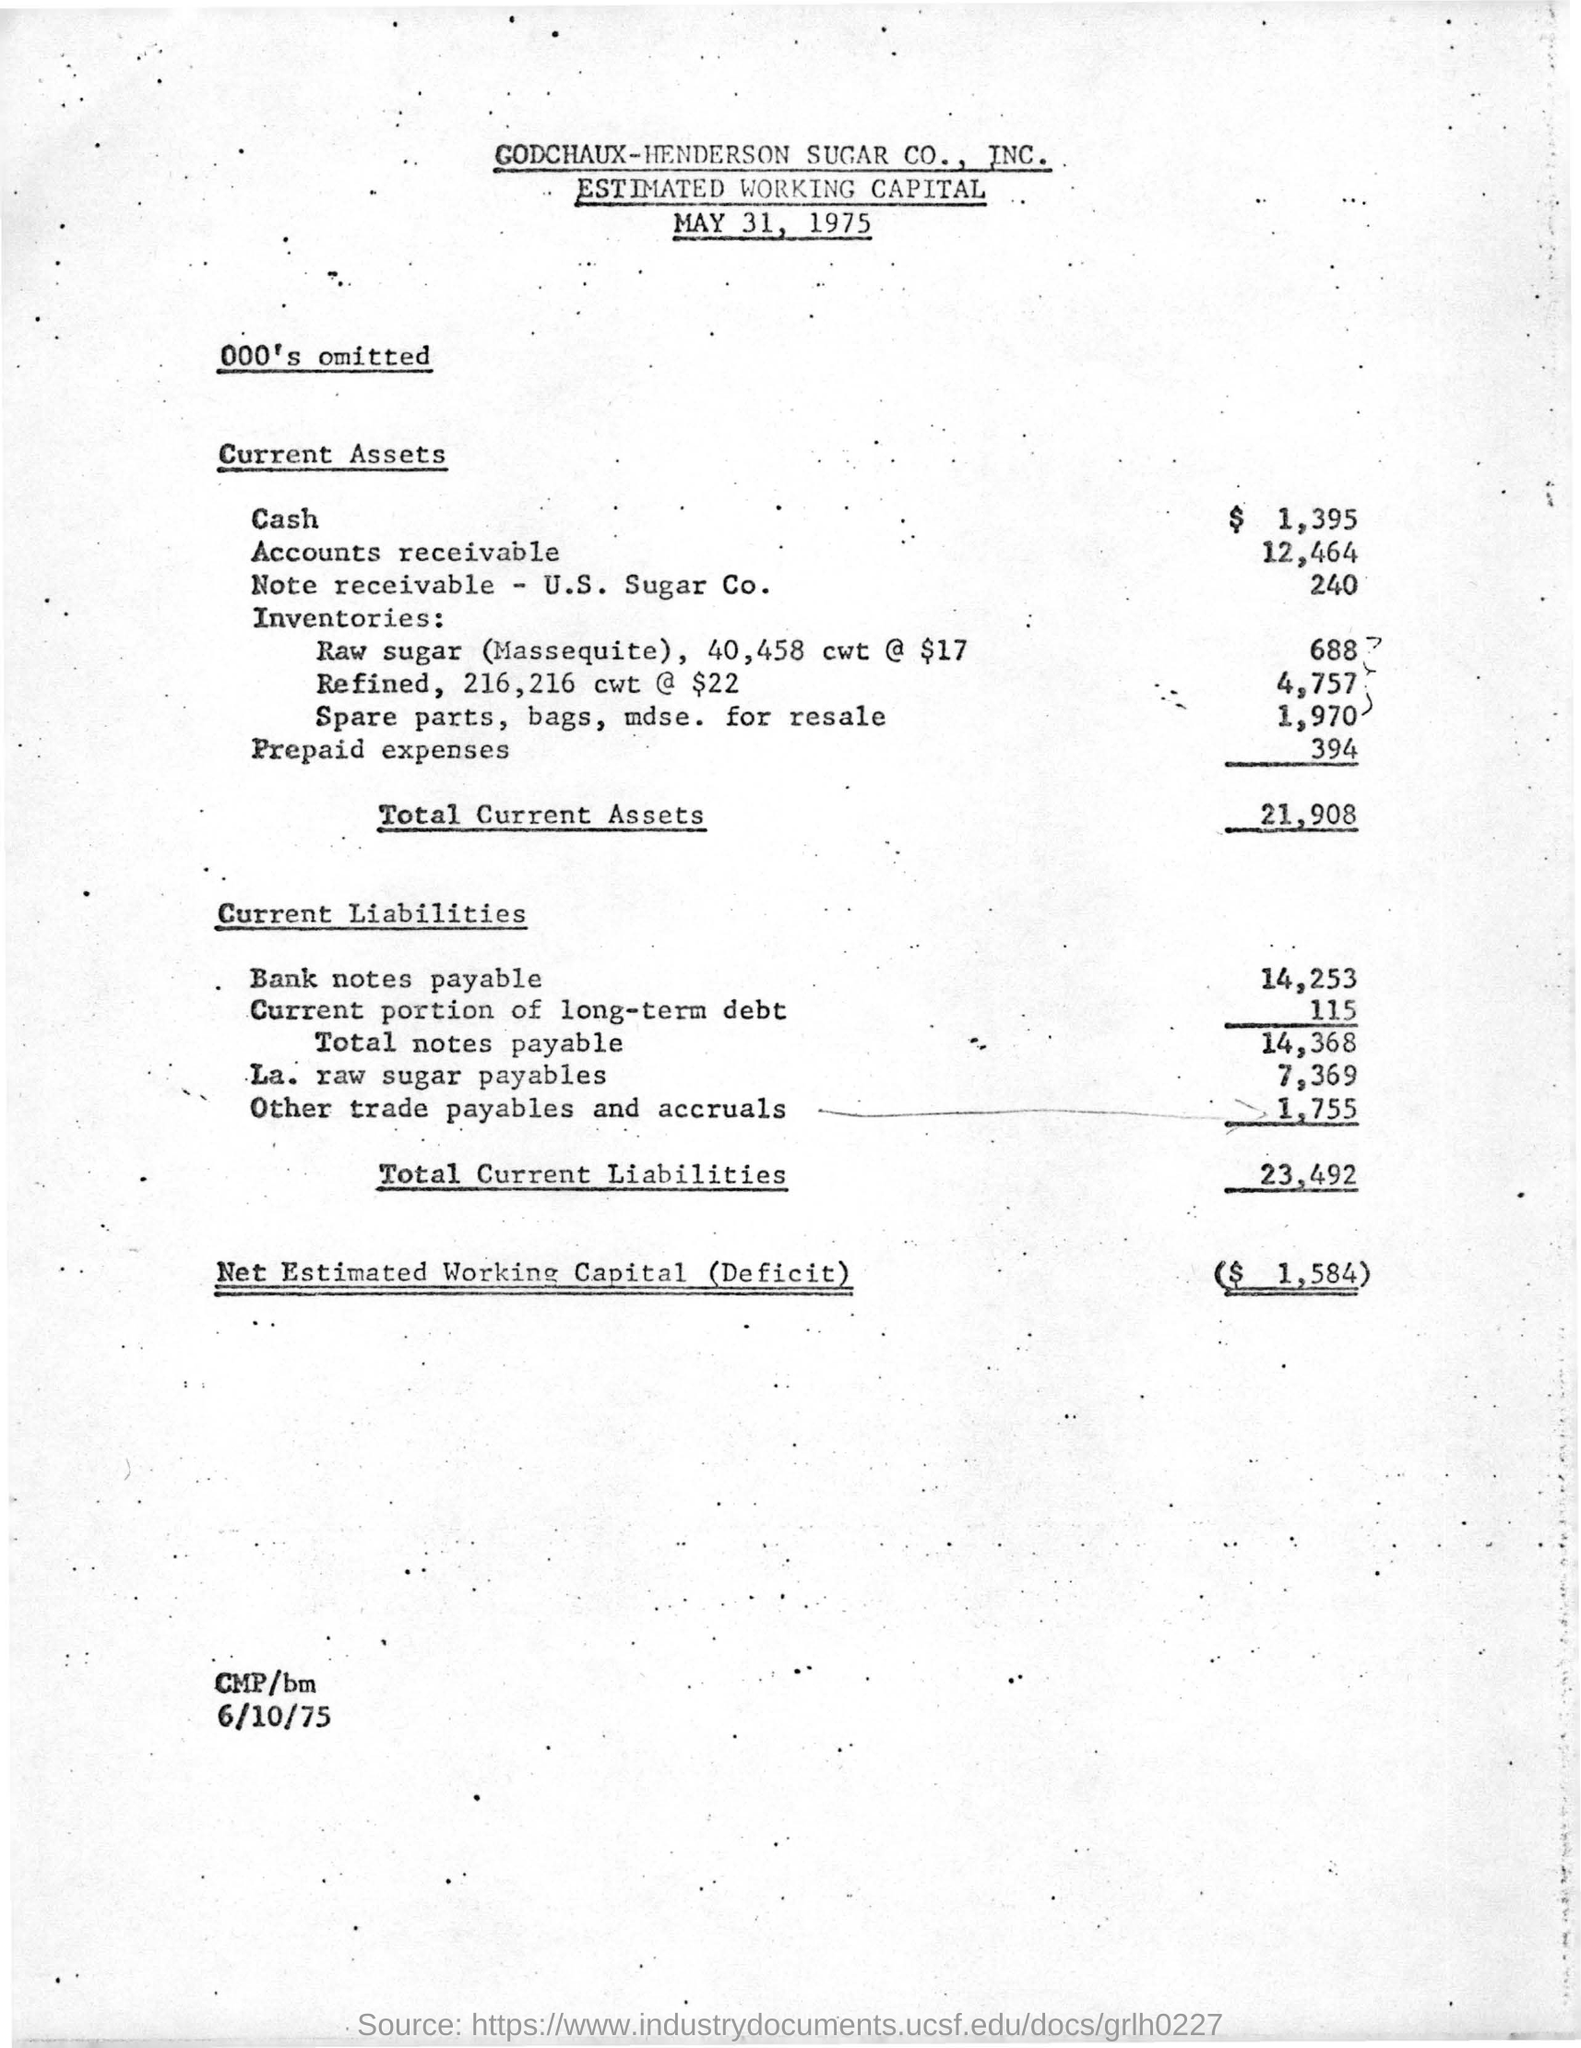What is written in top of the document ?
Offer a very short reply. GODCHAUX-HENDERSON SUGAR CO., INC. What is the date mentioned in the top of the document ?
Keep it short and to the point. MAY 31, 1975. What is the total amount of Current Assets?
Your response must be concise. 21,908. What is he total amount of Current Liabilities ?
Keep it short and to the point. 23,492. What is the Net Estimated Working Capital ?
Keep it short and to the point. $1,584. What is the date mentioned in the bottom of the document ?
Make the answer very short. 6/10/75. 